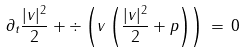<formula> <loc_0><loc_0><loc_500><loc_500>\partial _ { t } \frac { | v | ^ { 2 } } { 2 } + \div \left ( v \left ( \frac { | v | ^ { 2 } } { 2 } + p \right ) \right ) \, = \, 0</formula> 